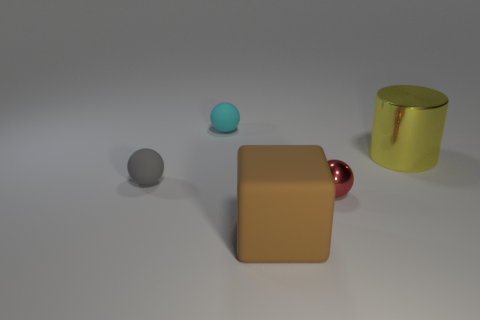Subtract all small cyan balls. How many balls are left? 2 Subtract 1 cubes. How many cubes are left? 0 Subtract all gray spheres. How many spheres are left? 2 Add 3 big rubber things. How many objects exist? 8 Subtract all cylinders. How many objects are left? 4 Add 5 red balls. How many red balls exist? 6 Subtract 1 brown blocks. How many objects are left? 4 Subtract all blue balls. Subtract all blue cylinders. How many balls are left? 3 Subtract all big purple metal balls. Subtract all brown matte objects. How many objects are left? 4 Add 4 small rubber objects. How many small rubber objects are left? 6 